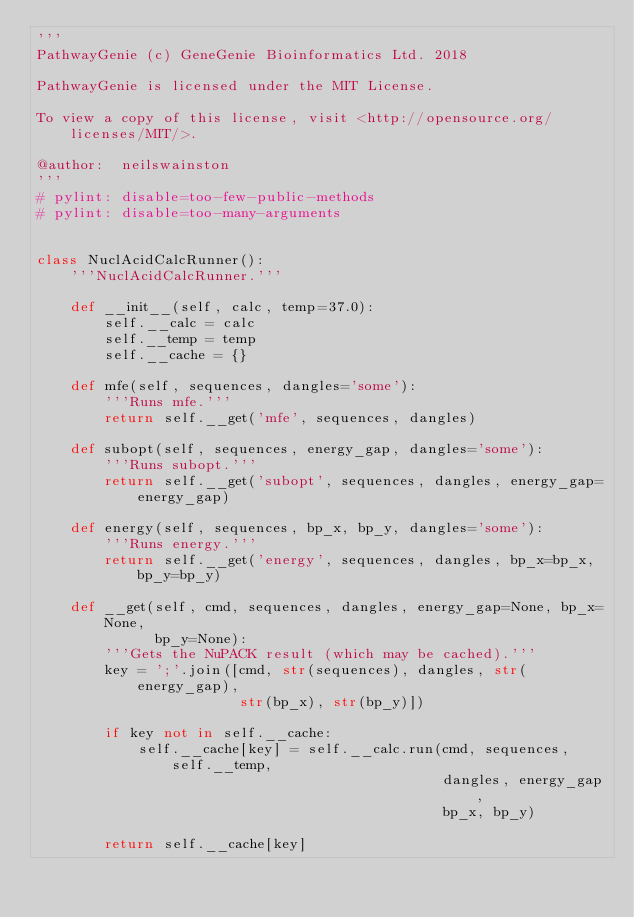<code> <loc_0><loc_0><loc_500><loc_500><_Python_>'''
PathwayGenie (c) GeneGenie Bioinformatics Ltd. 2018

PathwayGenie is licensed under the MIT License.

To view a copy of this license, visit <http://opensource.org/licenses/MIT/>.

@author:  neilswainston
'''
# pylint: disable=too-few-public-methods
# pylint: disable=too-many-arguments


class NuclAcidCalcRunner():
    '''NuclAcidCalcRunner.'''

    def __init__(self, calc, temp=37.0):
        self.__calc = calc
        self.__temp = temp
        self.__cache = {}

    def mfe(self, sequences, dangles='some'):
        '''Runs mfe.'''
        return self.__get('mfe', sequences, dangles)

    def subopt(self, sequences, energy_gap, dangles='some'):
        '''Runs subopt.'''
        return self.__get('subopt', sequences, dangles, energy_gap=energy_gap)

    def energy(self, sequences, bp_x, bp_y, dangles='some'):
        '''Runs energy.'''
        return self.__get('energy', sequences, dangles, bp_x=bp_x, bp_y=bp_y)

    def __get(self, cmd, sequences, dangles, energy_gap=None, bp_x=None,
              bp_y=None):
        '''Gets the NuPACK result (which may be cached).'''
        key = ';'.join([cmd, str(sequences), dangles, str(energy_gap),
                        str(bp_x), str(bp_y)])

        if key not in self.__cache:
            self.__cache[key] = self.__calc.run(cmd, sequences, self.__temp,
                                                dangles, energy_gap,
                                                bp_x, bp_y)

        return self.__cache[key]
</code> 